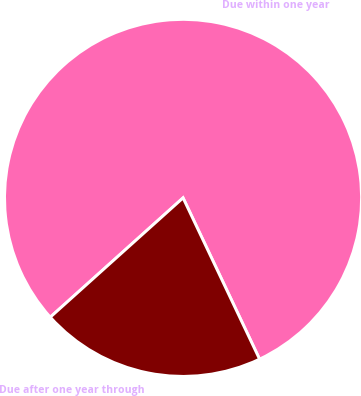<chart> <loc_0><loc_0><loc_500><loc_500><pie_chart><fcel>Due within one year<fcel>Due after one year through<nl><fcel>79.6%<fcel>20.4%<nl></chart> 